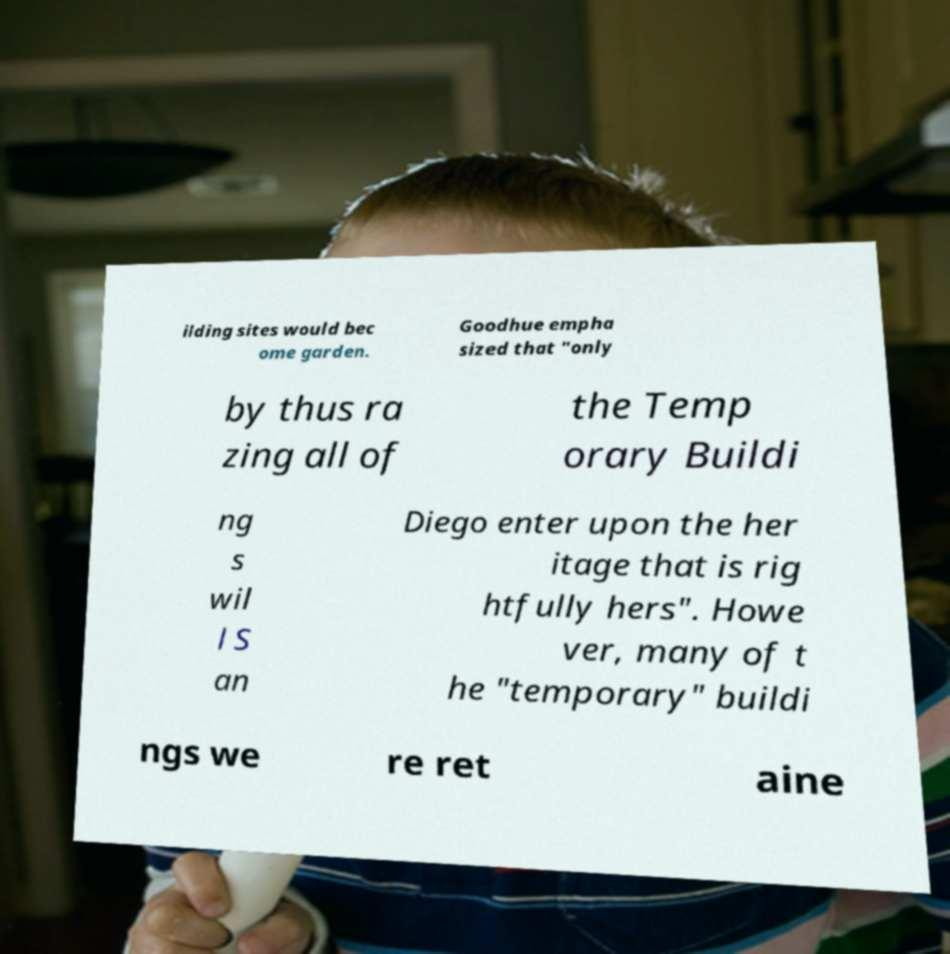For documentation purposes, I need the text within this image transcribed. Could you provide that? ilding sites would bec ome garden. Goodhue empha sized that "only by thus ra zing all of the Temp orary Buildi ng s wil l S an Diego enter upon the her itage that is rig htfully hers". Howe ver, many of t he "temporary" buildi ngs we re ret aine 